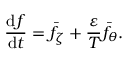<formula> <loc_0><loc_0><loc_500><loc_500>\frac { d f } { d t } = \bar { f } _ { \zeta } + \frac { \varepsilon } { T } \bar { f } _ { \theta } .</formula> 